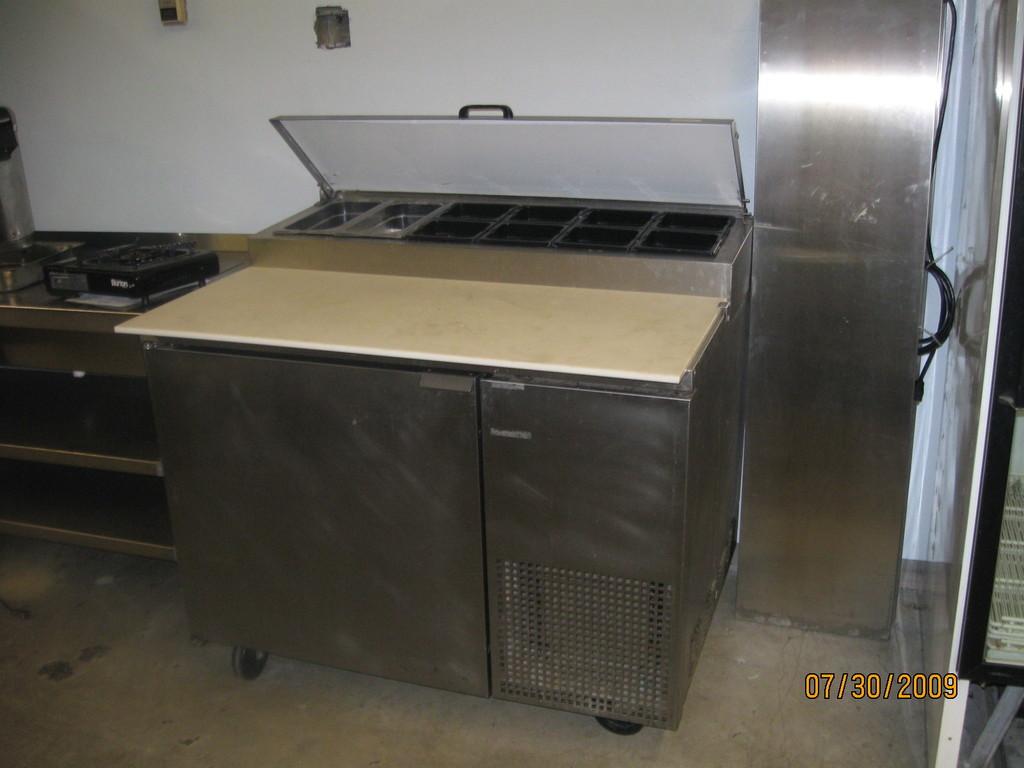When was this photo taken?
Your answer should be compact. 07/30/2009. What year was this photo taken?
Offer a very short reply. 2009. 